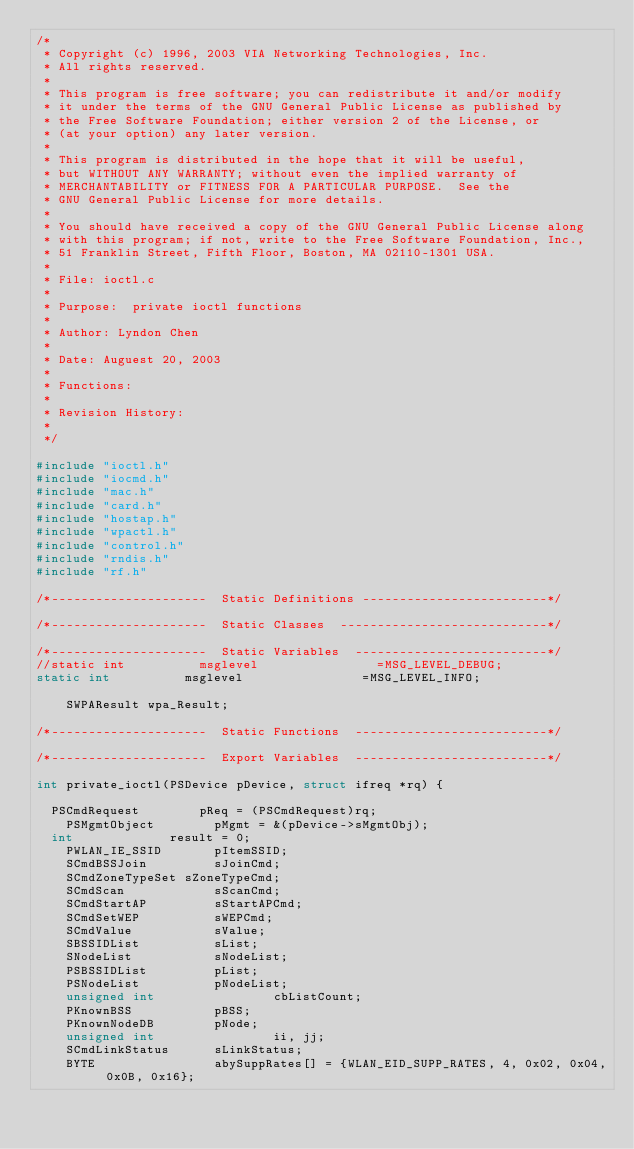Convert code to text. <code><loc_0><loc_0><loc_500><loc_500><_C_>/*
 * Copyright (c) 1996, 2003 VIA Networking Technologies, Inc.
 * All rights reserved.
 *
 * This program is free software; you can redistribute it and/or modify
 * it under the terms of the GNU General Public License as published by
 * the Free Software Foundation; either version 2 of the License, or
 * (at your option) any later version.
 *
 * This program is distributed in the hope that it will be useful,
 * but WITHOUT ANY WARRANTY; without even the implied warranty of
 * MERCHANTABILITY or FITNESS FOR A PARTICULAR PURPOSE.  See the
 * GNU General Public License for more details.
 *
 * You should have received a copy of the GNU General Public License along
 * with this program; if not, write to the Free Software Foundation, Inc.,
 * 51 Franklin Street, Fifth Floor, Boston, MA 02110-1301 USA.
 *
 * File: ioctl.c
 *
 * Purpose:  private ioctl functions
 *
 * Author: Lyndon Chen
 *
 * Date: Auguest 20, 2003
 *
 * Functions:
 *
 * Revision History:
 *
 */

#include "ioctl.h"
#include "iocmd.h"
#include "mac.h"
#include "card.h"
#include "hostap.h"
#include "wpactl.h"
#include "control.h"
#include "rndis.h"
#include "rf.h"

/*---------------------  Static Definitions -------------------------*/

/*---------------------  Static Classes  ----------------------------*/

/*---------------------  Static Variables  --------------------------*/
//static int          msglevel                =MSG_LEVEL_DEBUG;
static int          msglevel                =MSG_LEVEL_INFO;

    SWPAResult wpa_Result;

/*---------------------  Static Functions  --------------------------*/

/*---------------------  Export Variables  --------------------------*/

int private_ioctl(PSDevice pDevice, struct ifreq *rq) {

	PSCmdRequest        pReq = (PSCmdRequest)rq;
    PSMgmtObject        pMgmt = &(pDevice->sMgmtObj);
	int 		        result = 0;
    PWLAN_IE_SSID       pItemSSID;
    SCmdBSSJoin         sJoinCmd;
    SCmdZoneTypeSet sZoneTypeCmd;
    SCmdScan            sScanCmd;
    SCmdStartAP         sStartAPCmd;
    SCmdSetWEP          sWEPCmd;
    SCmdValue           sValue;
    SBSSIDList          sList;
    SNodeList           sNodeList;
    PSBSSIDList         pList;
    PSNodeList          pNodeList;
    unsigned int                cbListCount;
    PKnownBSS           pBSS;
    PKnownNodeDB        pNode;
    unsigned int                ii, jj;
    SCmdLinkStatus      sLinkStatus;
    BYTE                abySuppRates[] = {WLAN_EID_SUPP_RATES, 4, 0x02, 0x04, 0x0B, 0x16};</code> 